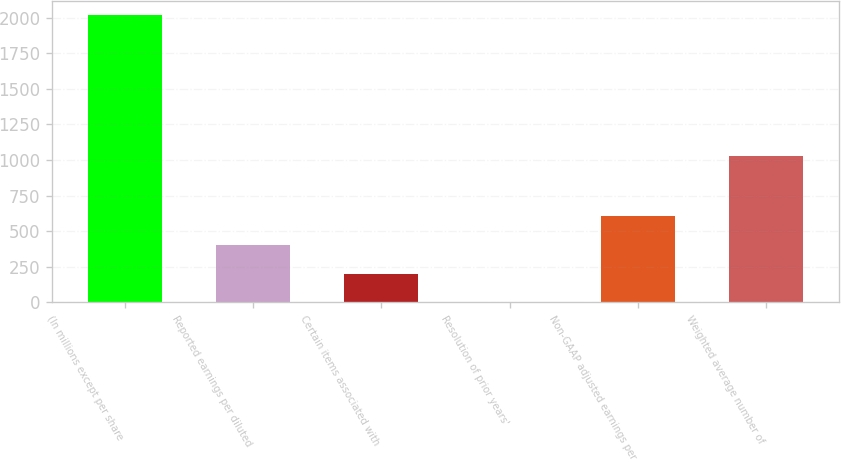<chart> <loc_0><loc_0><loc_500><loc_500><bar_chart><fcel>(In millions except per share<fcel>Reported earnings per diluted<fcel>Certain items associated with<fcel>Resolution of prior years'<fcel>Non-GAAP adjusted earnings per<fcel>Weighted average number of<nl><fcel>2018<fcel>403.62<fcel>201.82<fcel>0.02<fcel>605.42<fcel>1026<nl></chart> 